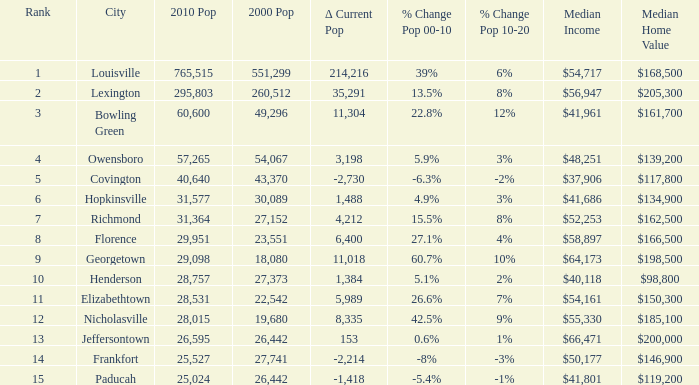What was the 2010 population of frankfort which has a rank smaller than 14? None. 